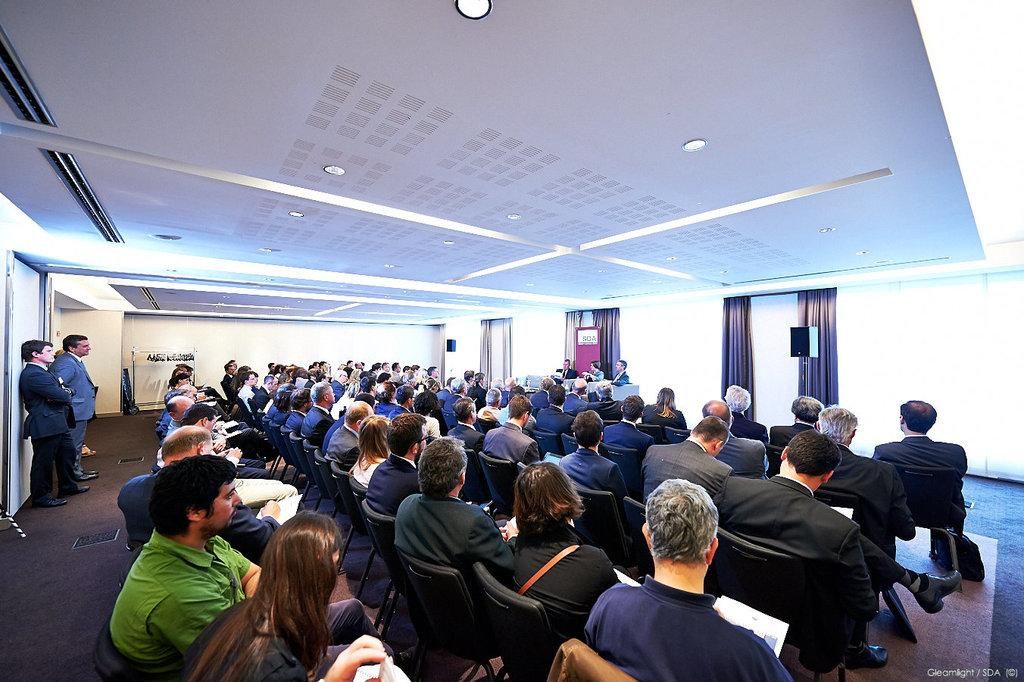How many people are in the image? There are people in the image, but the exact number is not specified. What are some people doing in the image? Some people are sitting on chairs, and some are holding papers. What can be seen in the image that provides light? There are lights in the image. What type of window treatment is present in the image? There are curtains in the image. What piece of furniture is visible in the image? There is a table in the image. What part of the room can be seen in the image? The walls are visible in the image. What type of string instrument can be heard playing in the image? There is no string instrument or any sound mentioned in the image, so it is not possible to determine if one can be heard. 